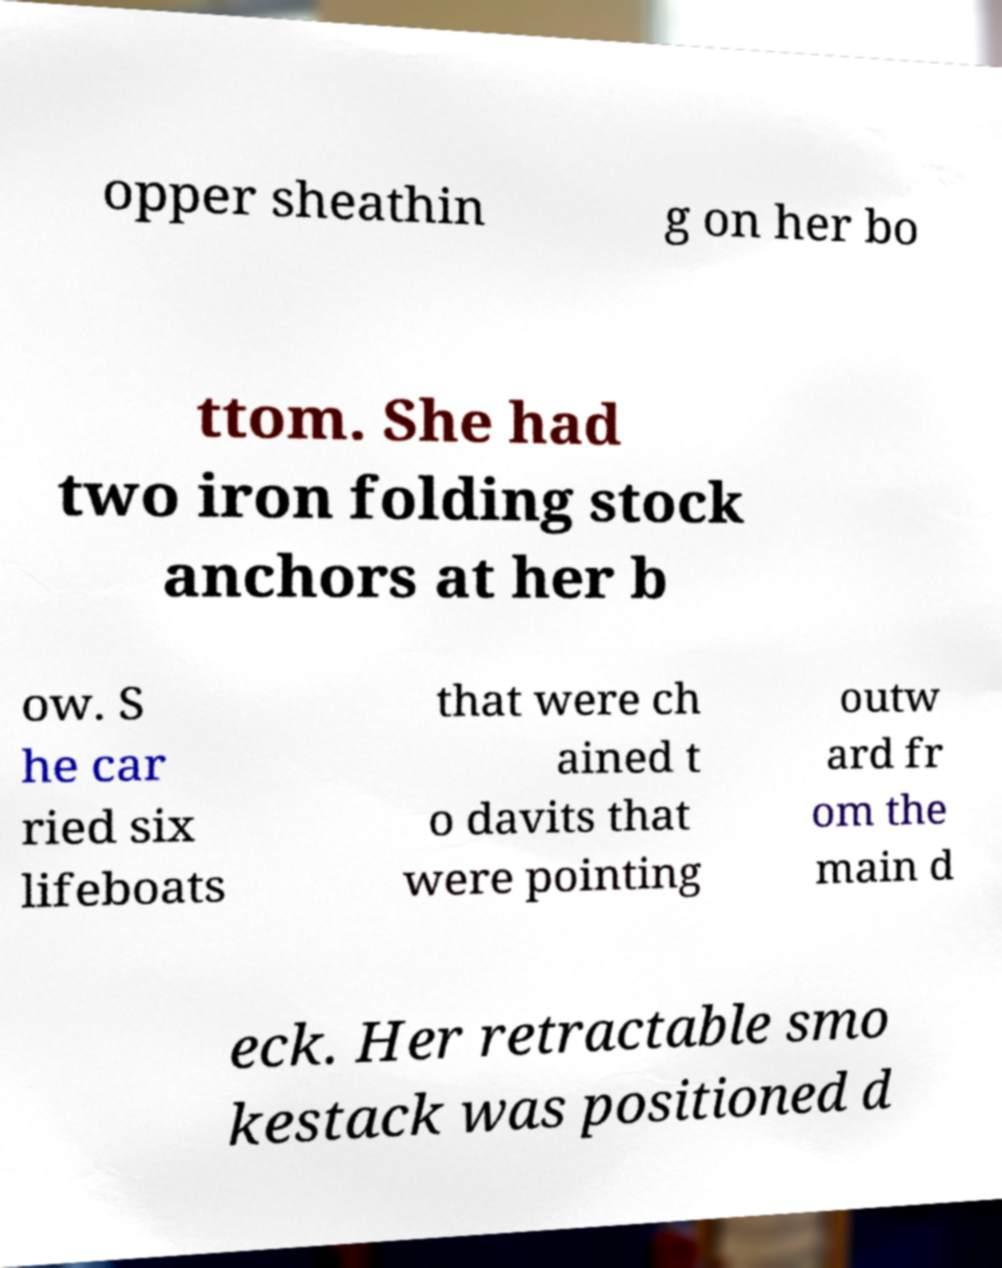Can you accurately transcribe the text from the provided image for me? opper sheathin g on her bo ttom. She had two iron folding stock anchors at her b ow. S he car ried six lifeboats that were ch ained t o davits that were pointing outw ard fr om the main d eck. Her retractable smo kestack was positioned d 